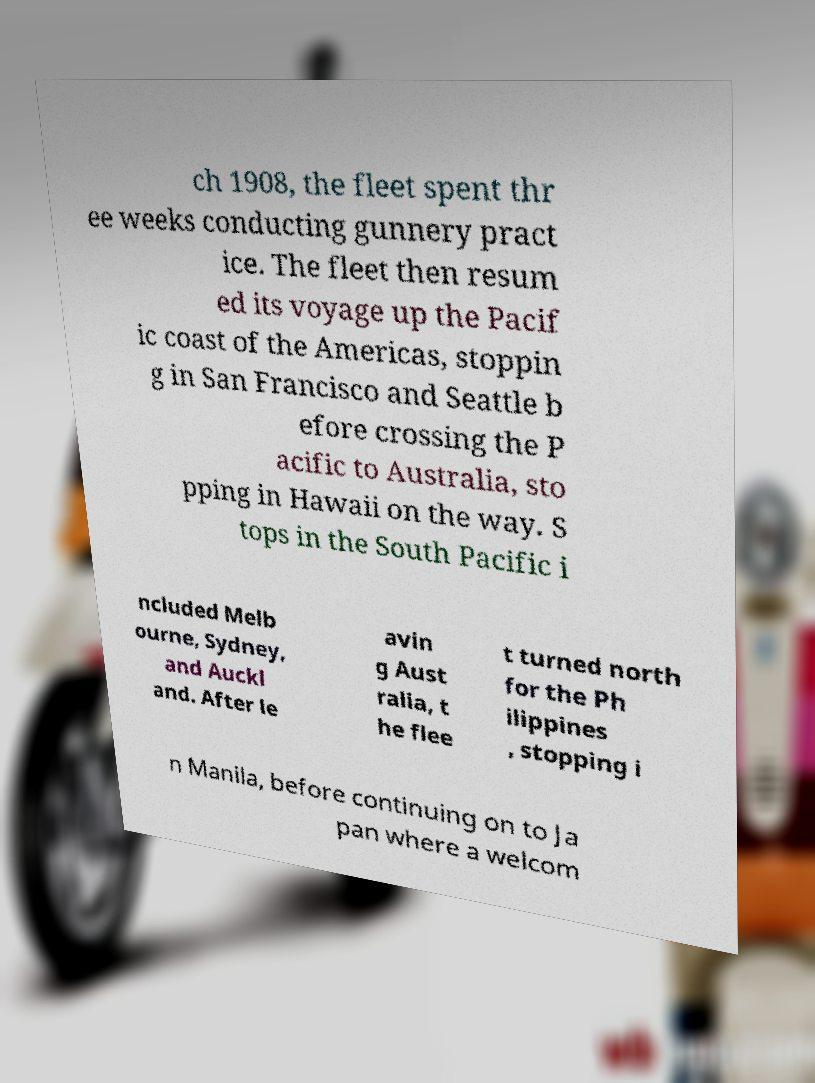Can you read and provide the text displayed in the image?This photo seems to have some interesting text. Can you extract and type it out for me? ch 1908, the fleet spent thr ee weeks conducting gunnery pract ice. The fleet then resum ed its voyage up the Pacif ic coast of the Americas, stoppin g in San Francisco and Seattle b efore crossing the P acific to Australia, sto pping in Hawaii on the way. S tops in the South Pacific i ncluded Melb ourne, Sydney, and Auckl and. After le avin g Aust ralia, t he flee t turned north for the Ph ilippines , stopping i n Manila, before continuing on to Ja pan where a welcom 